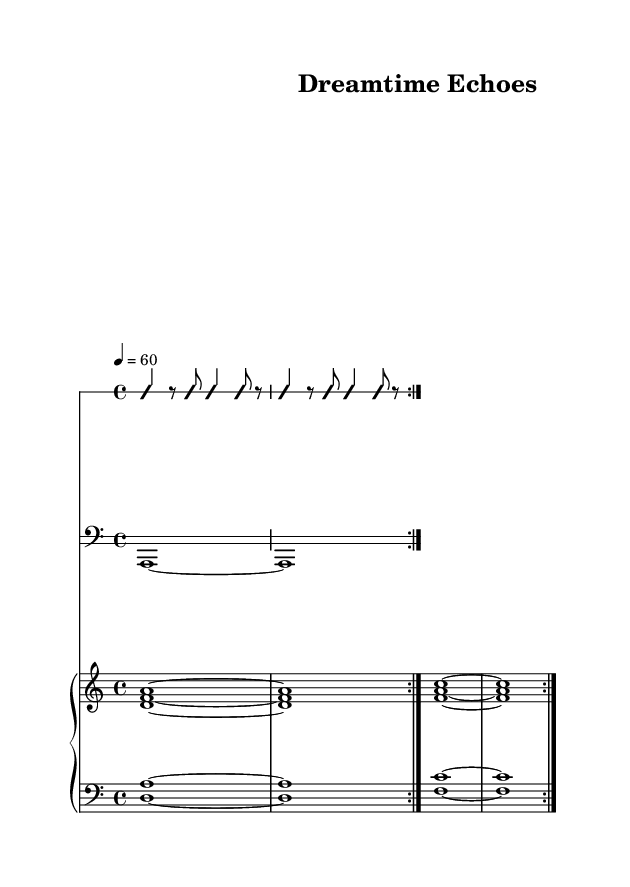What is the time signature of this music? The time signature is indicated at the beginning of the piece as 4/4, meaning four beats in each measure.
Answer: 4/4 What is the tempo of the music? The tempo is marked as "4 = 60," indicating that there are 60 beats per minute and each quarter note gets one beat.
Answer: 60 How many volta sections are present in the score? The score indicates "volta 2," which means there are two repeat sections that will be played before moving on.
Answer: 2 What is the clef used in the bass staff? The bass staff is marked with a bass clef symbol, typically used for lower-pitched instruments.
Answer: Bass clef What is the primary chord progression used in the piano staff? The progression alternates primarily between the chords D minor and F major, evident from the notes that are played in sequence.
Answer: D minor to F major How does the rhythmic staff contribute to the overall composition? The rhythmic staff provides a percussive element with improvised rhythms, creating an ambient sound that complements the didgeridoo and throat singing.
Answer: Ambient rhythms What is a unique characteristic of combining didgeridoo and throat singing in this piece? The piece uniquely features the blending of didgeridoo drone sounds with multifaceted vocal harmonics, creating a rich soundscape.
Answer: Rich soundscape 